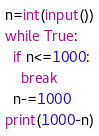<code> <loc_0><loc_0><loc_500><loc_500><_Python_>n=int(input())
while True:
  if n<=1000:
    break
  n-=1000
print(1000-n)</code> 